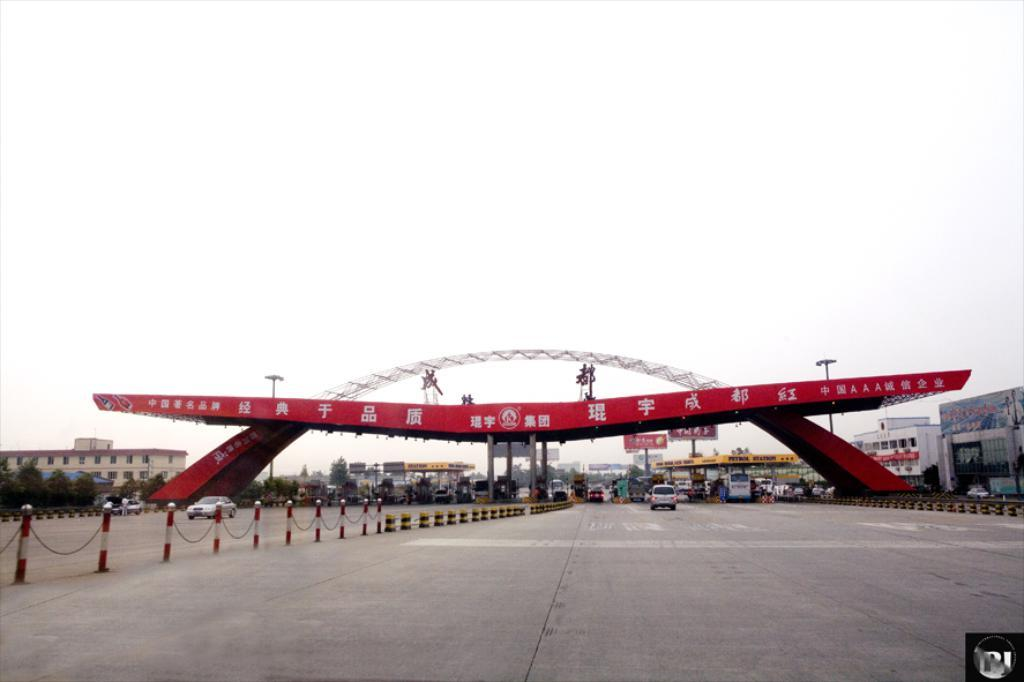What is the main structure in the center of the image? There is an arch in the center of the image. What is located at the bottom of the image? There is a road at the bottom of the image. What can be seen on the road? There are vehicles on the road. What is visible in the background of the image? There are buildings, poles, trees, and the sky visible in the background of the image. What type of cup is being used to control the behavior of the vehicles on the road? There is no cup present in the image, nor is there any indication of controlling the behavior of vehicles. 